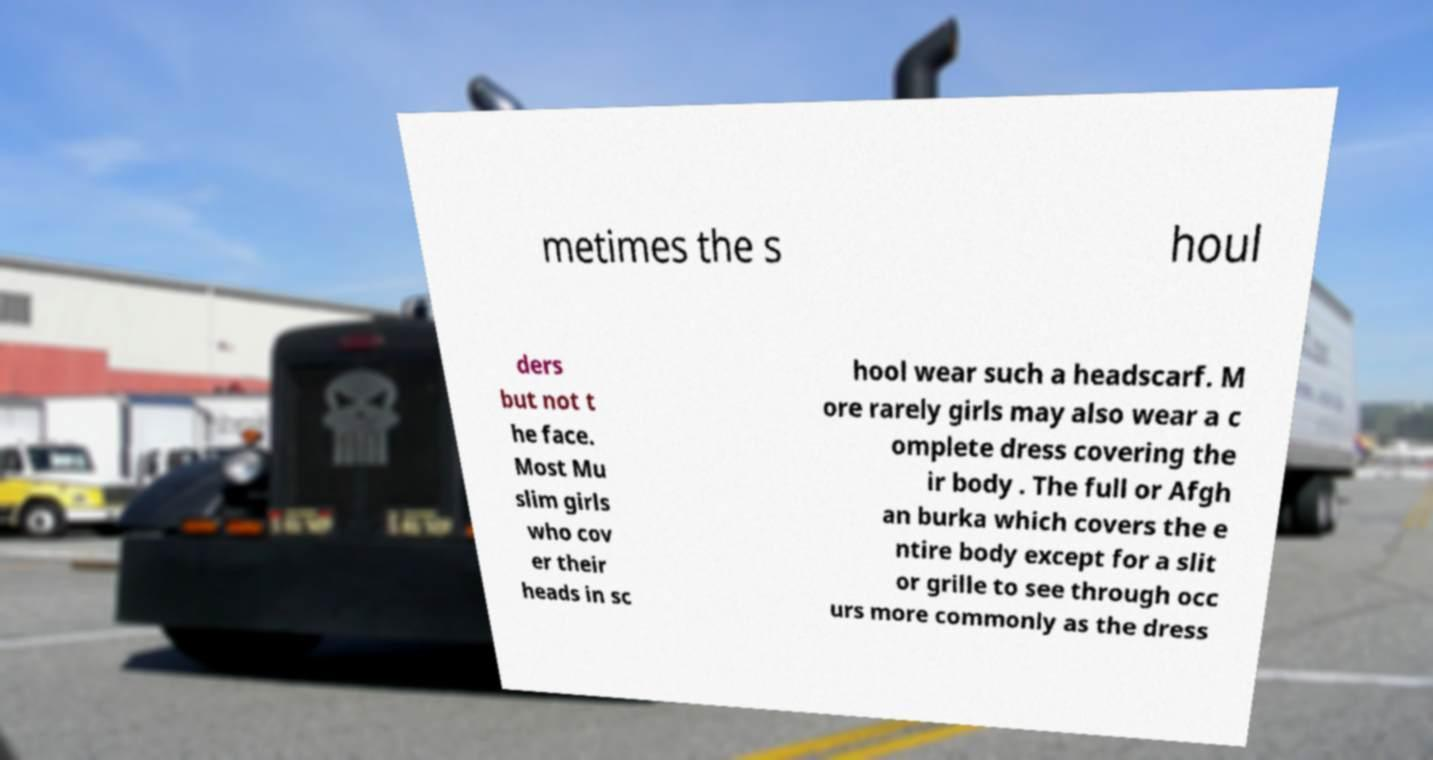Please read and relay the text visible in this image. What does it say? metimes the s houl ders but not t he face. Most Mu slim girls who cov er their heads in sc hool wear such a headscarf. M ore rarely girls may also wear a c omplete dress covering the ir body . The full or Afgh an burka which covers the e ntire body except for a slit or grille to see through occ urs more commonly as the dress 